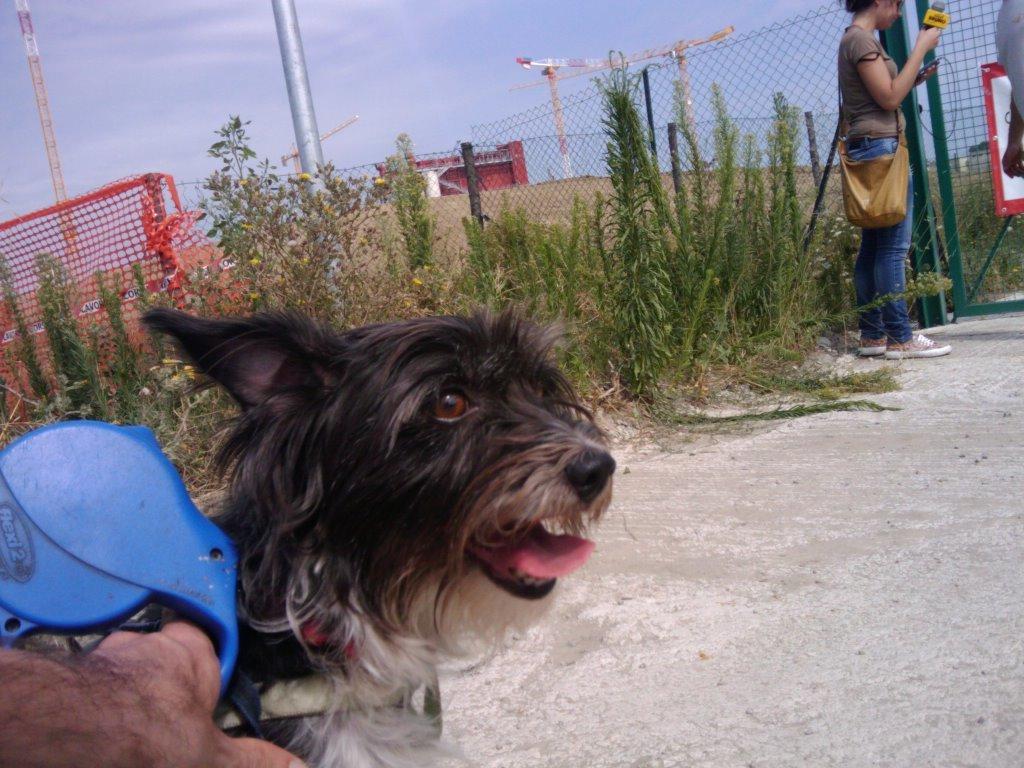Describe this image in one or two sentences. In this image we can see a dog and a road. In the background, we can see plants, mesh, poles and a woman. The woman is wearing a T-shirt, jeans, carrying bag and holding a mic in her hand. At the top of the image, we can see the sky. We can see a human hand and a blue color object in the left bottom of the image. 